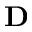Convert formula to latex. <formula><loc_0><loc_0><loc_500><loc_500>{ D }</formula> 